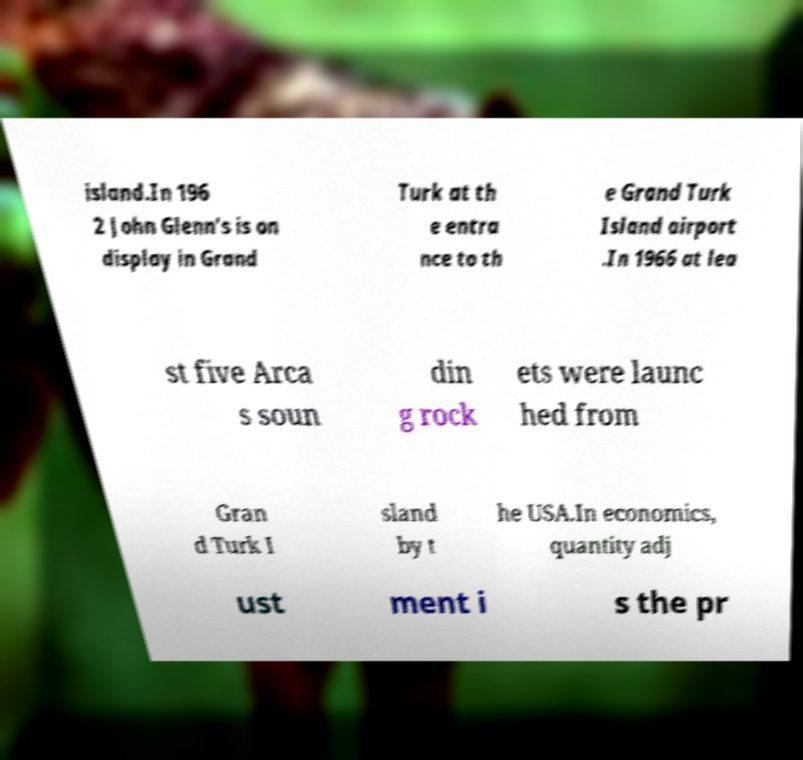Please read and relay the text visible in this image. What does it say? island.In 196 2 John Glenn's is on display in Grand Turk at th e entra nce to th e Grand Turk Island airport .In 1966 at lea st five Arca s soun din g rock ets were launc hed from Gran d Turk I sland by t he USA.In economics, quantity adj ust ment i s the pr 